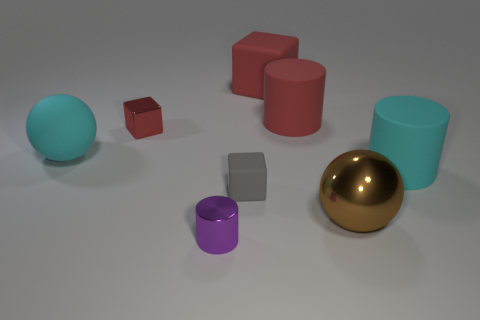There is a cylinder that is on the left side of the big brown metal sphere and to the right of the gray object; how big is it? The cylinder on the left side of the large brown metallic sphere appears to be smaller in size compared to the sphere itself, with a diameter roughly a third of the sphere's. 